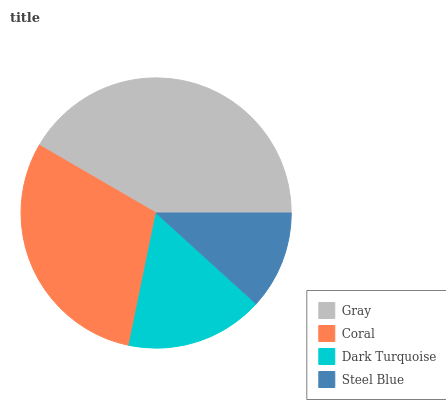Is Steel Blue the minimum?
Answer yes or no. Yes. Is Gray the maximum?
Answer yes or no. Yes. Is Coral the minimum?
Answer yes or no. No. Is Coral the maximum?
Answer yes or no. No. Is Gray greater than Coral?
Answer yes or no. Yes. Is Coral less than Gray?
Answer yes or no. Yes. Is Coral greater than Gray?
Answer yes or no. No. Is Gray less than Coral?
Answer yes or no. No. Is Coral the high median?
Answer yes or no. Yes. Is Dark Turquoise the low median?
Answer yes or no. Yes. Is Dark Turquoise the high median?
Answer yes or no. No. Is Gray the low median?
Answer yes or no. No. 